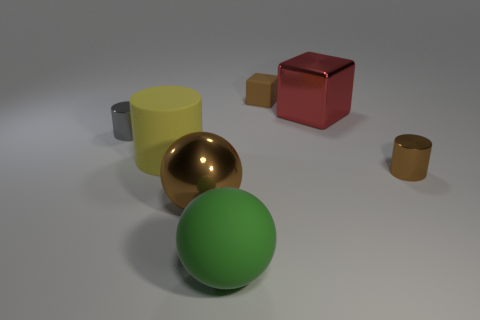There is a large matte object in front of the large brown sphere; is its shape the same as the small gray object?
Your answer should be very brief. No. There is a cylinder in front of the large yellow matte cylinder; what is its material?
Give a very brief answer. Metal. The big object that is the same color as the tiny cube is what shape?
Provide a short and direct response. Sphere. Are there any large things made of the same material as the small gray cylinder?
Your answer should be very brief. Yes. What size is the yellow object?
Provide a succinct answer. Large. How many gray objects are either large rubber objects or cylinders?
Make the answer very short. 1. What number of large brown metallic things have the same shape as the green thing?
Offer a very short reply. 1. How many cylinders are the same size as the brown rubber thing?
Offer a very short reply. 2. There is a tiny brown object that is the same shape as the gray object; what is it made of?
Give a very brief answer. Metal. There is a metallic cylinder that is left of the brown metal cylinder; what color is it?
Your answer should be very brief. Gray. 